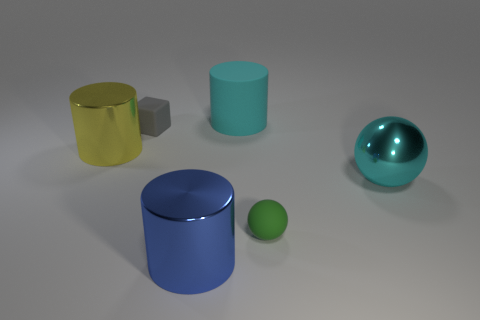Add 1 tiny blue rubber blocks. How many objects exist? 7 Subtract all spheres. How many objects are left? 4 Subtract 0 gray cylinders. How many objects are left? 6 Subtract all small yellow matte things. Subtract all small balls. How many objects are left? 5 Add 6 large yellow objects. How many large yellow objects are left? 7 Add 5 cyan metallic balls. How many cyan metallic balls exist? 6 